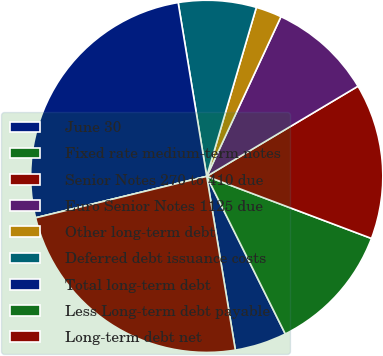Convert chart to OTSL. <chart><loc_0><loc_0><loc_500><loc_500><pie_chart><fcel>June 30<fcel>Fixed rate medium-term notes<fcel>Senior Notes 270 to 410 due<fcel>Euro Senior Notes 1125 due<fcel>Other long-term debt<fcel>Deferred debt issuance costs<fcel>Total long-term debt<fcel>Less Long-term debt payable<fcel>Long-term debt net<nl><fcel>4.76%<fcel>11.9%<fcel>14.29%<fcel>9.52%<fcel>2.38%<fcel>7.14%<fcel>26.19%<fcel>0.0%<fcel>23.81%<nl></chart> 